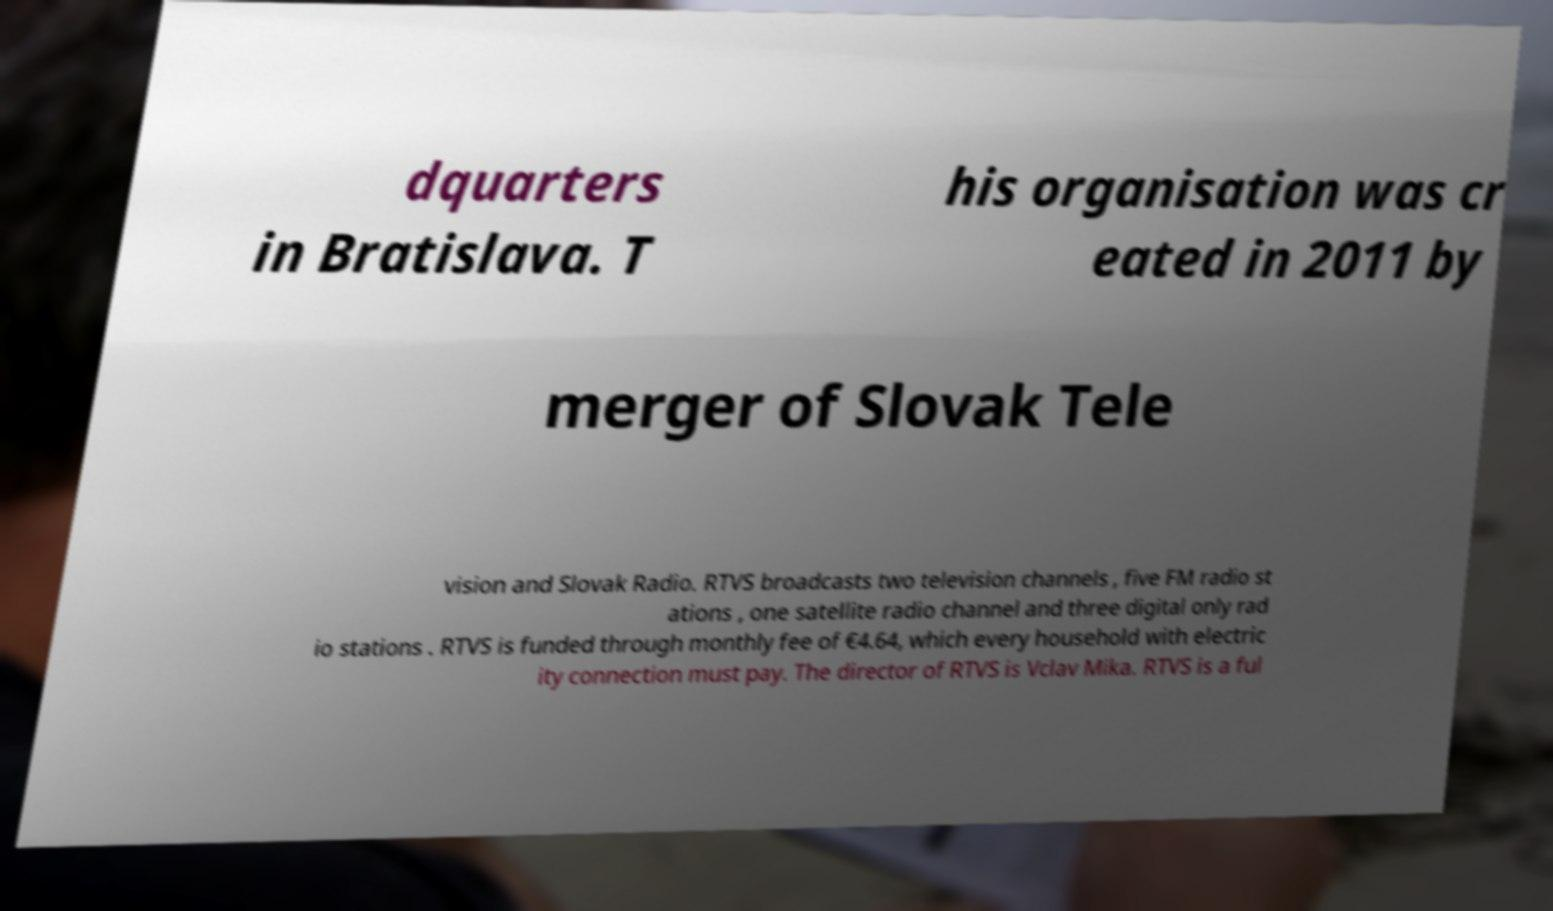There's text embedded in this image that I need extracted. Can you transcribe it verbatim? dquarters in Bratislava. T his organisation was cr eated in 2011 by merger of Slovak Tele vision and Slovak Radio. RTVS broadcasts two television channels , five FM radio st ations , one satellite radio channel and three digital only rad io stations . RTVS is funded through monthly fee of €4.64, which every household with electric ity connection must pay. The director of RTVS is Vclav Mika. RTVS is a ful 